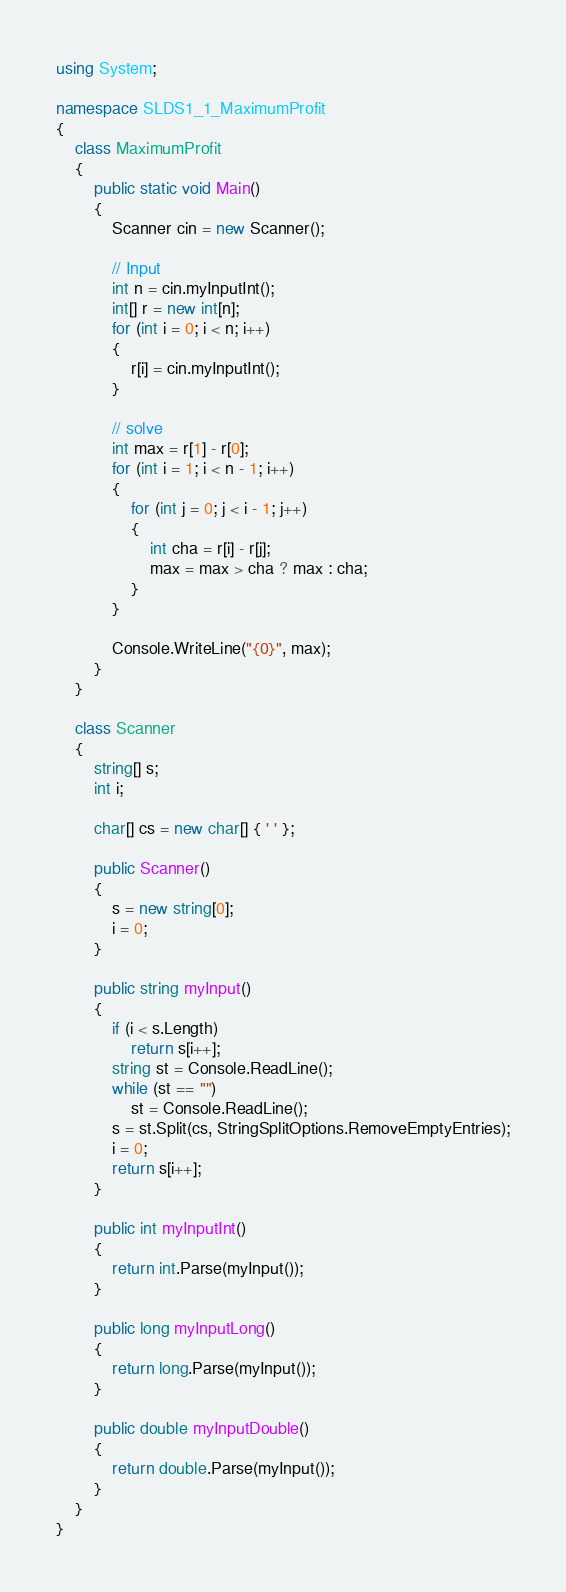Convert code to text. <code><loc_0><loc_0><loc_500><loc_500><_C#_>using System;

namespace SLDS1_1_MaximumProfit
{
    class MaximumProfit
    {
        public static void Main()
        {
            Scanner cin = new Scanner();

            // Input
            int n = cin.myInputInt();
            int[] r = new int[n];
            for (int i = 0; i < n; i++)
            {
                r[i] = cin.myInputInt();
            }

            // solve
            int max = r[1] - r[0];
            for (int i = 1; i < n - 1; i++)
            {
                for (int j = 0; j < i - 1; j++)
                {
                    int cha = r[i] - r[j];
                    max = max > cha ? max : cha;
                }
            }

            Console.WriteLine("{0}", max);
        }
    }

    class Scanner
    {
        string[] s;
        int i;

        char[] cs = new char[] { ' ' };

        public Scanner()
        {
            s = new string[0];
            i = 0;
        }

        public string myInput()
        {
            if (i < s.Length)
                return s[i++];
            string st = Console.ReadLine();
            while (st == "")
                st = Console.ReadLine();
            s = st.Split(cs, StringSplitOptions.RemoveEmptyEntries);
            i = 0;
            return s[i++];
        }

        public int myInputInt()
        {
            return int.Parse(myInput());
        }

        public long myInputLong()
        {
            return long.Parse(myInput());
        }

        public double myInputDouble()
        {
            return double.Parse(myInput());
        }
    }
}</code> 